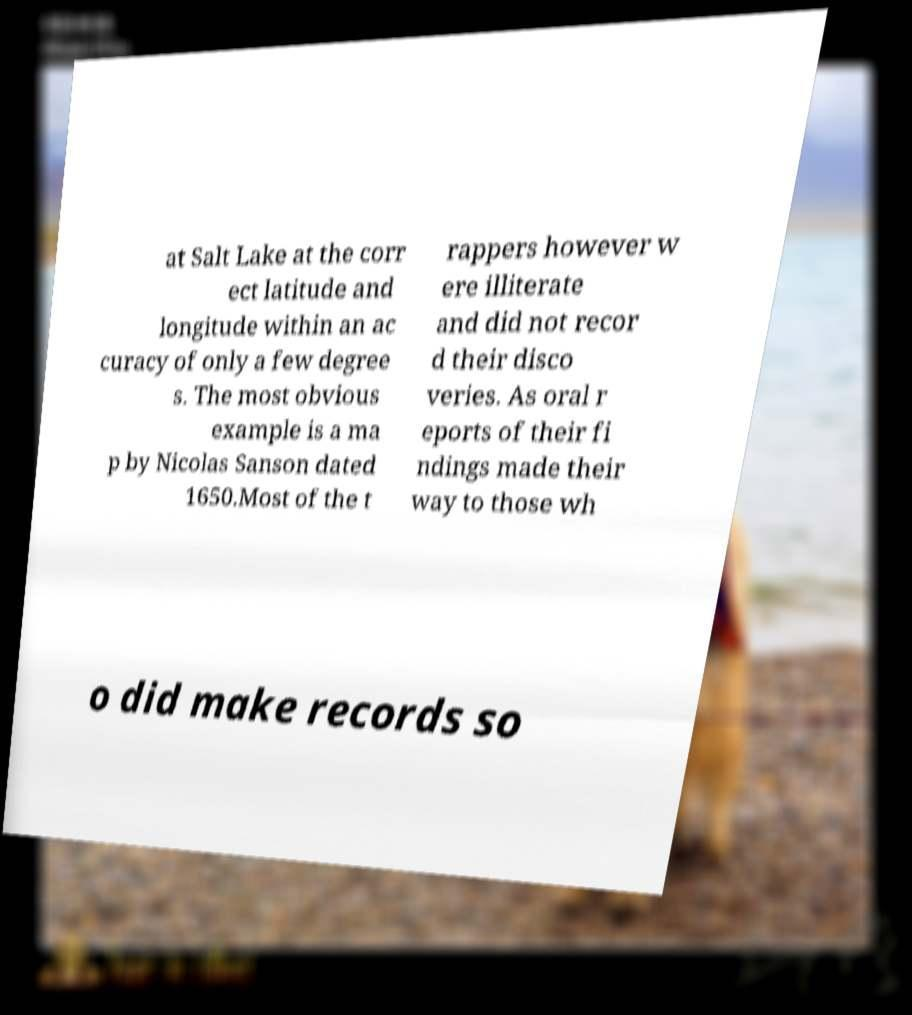There's text embedded in this image that I need extracted. Can you transcribe it verbatim? at Salt Lake at the corr ect latitude and longitude within an ac curacy of only a few degree s. The most obvious example is a ma p by Nicolas Sanson dated 1650.Most of the t rappers however w ere illiterate and did not recor d their disco veries. As oral r eports of their fi ndings made their way to those wh o did make records so 